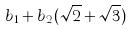<formula> <loc_0><loc_0><loc_500><loc_500>b _ { 1 } + b _ { 2 } ( \sqrt { 2 } + \sqrt { 3 } )</formula> 